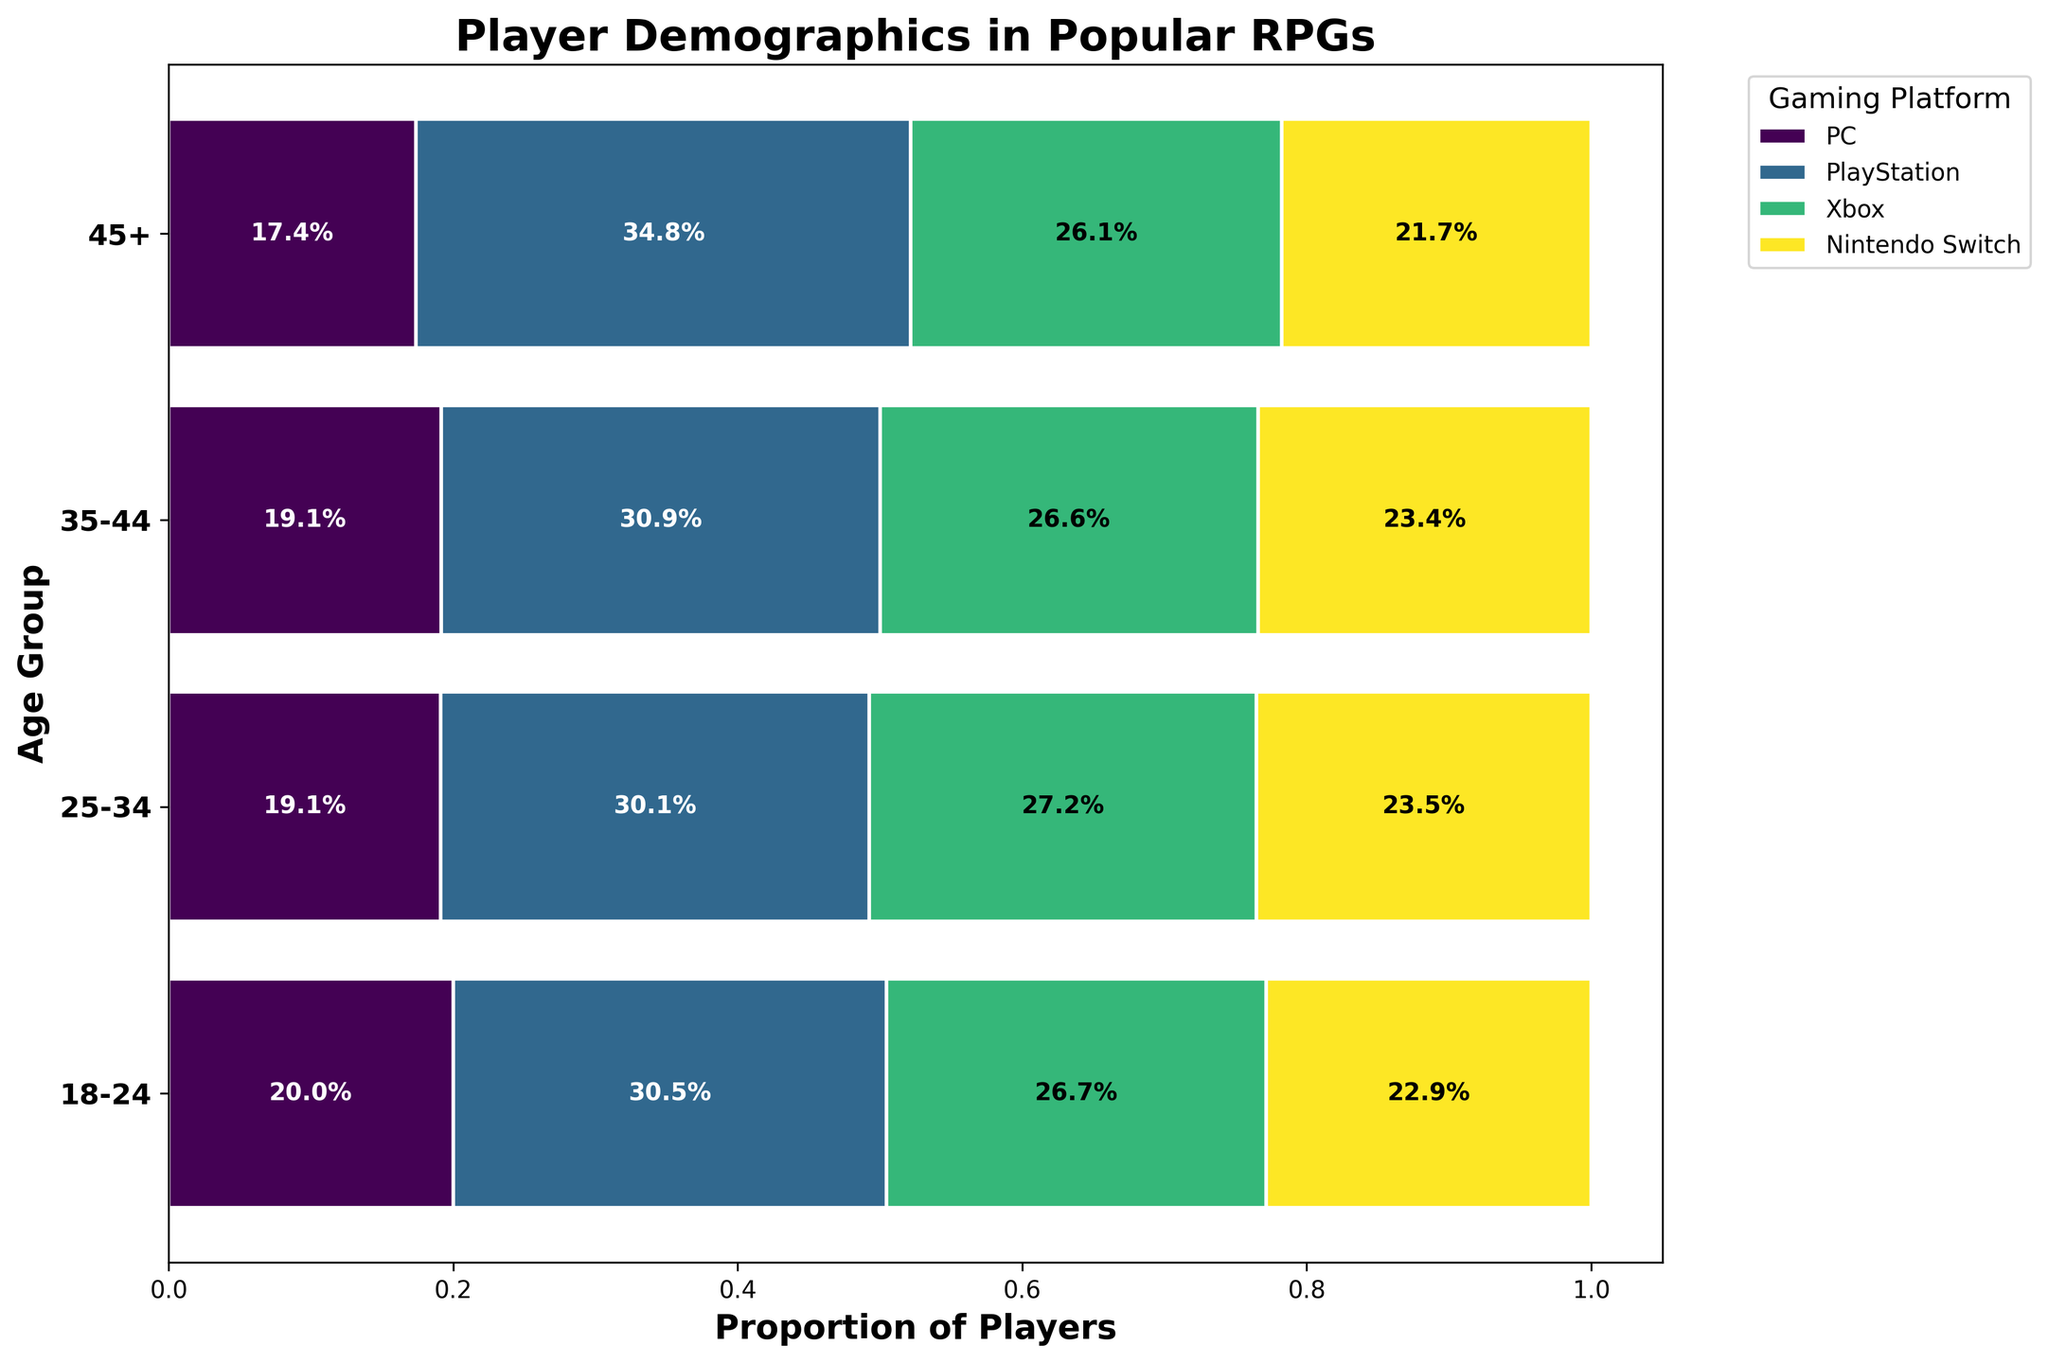What is the title of the plot? The title is displayed at the top of the plot in a bold font. It describes the overall theme of the visualized data.
Answer: Player Demographics in Popular RPGs Which gaming platform has the largest proportion of players in the 25-34 age group? In the stacked horizontal bar corresponding to the 25-34 age group, the segment representing PC is the largest width-wise.
Answer: PC What percentage of players aged 45+ use the Nintendo Switch? Look at the segment for Nintendo Switch in the 45+ age group and read the percentage label positioned inside this segment.
Answer: 8.3% Which age group has the smallest number of total players? By comparing the sum of all platforms' widths for each age group, the 45+ age group has the smallest combined width.
Answer: 45+ What is the combined percentage of players using PlayStation in the 18-24 and 35-44 age groups? Add the percentages from the PlayStation segments in the 18-24 and 35-44 age groups: 28% + 25%.
Answer: 53% How does the distribution of players between platforms change from the 18-24 age group to the 35-44 age group? Compare the width of each platform's segment between these two age groups; the differences show the change in distribution. For example, the proportion of PC players increases slightly, and Xbox players slightly decrease.
Answer: Varies: PC increases, Xbox decreases What age group has the highest proportion of Xbox players? Compare the width of the Xbox segments across all age groups. The 18-24 age group shows the widest segment for Xbox.
Answer: 18-24 Which platform has an almost even distribution across all age groups? By visually comparing each segment across different age groups, PlayStation appears to have relatively consistent width across all age groups.
Answer: PlayStation What is the difference in the proportion of PC players between the 25-34 and 45+ age groups? Subtract the percentage of PC players in the 45+ age group from the percentage in the 25-34 age group: 41% - 27.6%.
Answer: 13.4% What is the total proportion of players using PC across all age groups? Sum the proportions of PC players in each age group: 32% + 41% + 34.1% + 27.6%.
Answer: 134.7% 